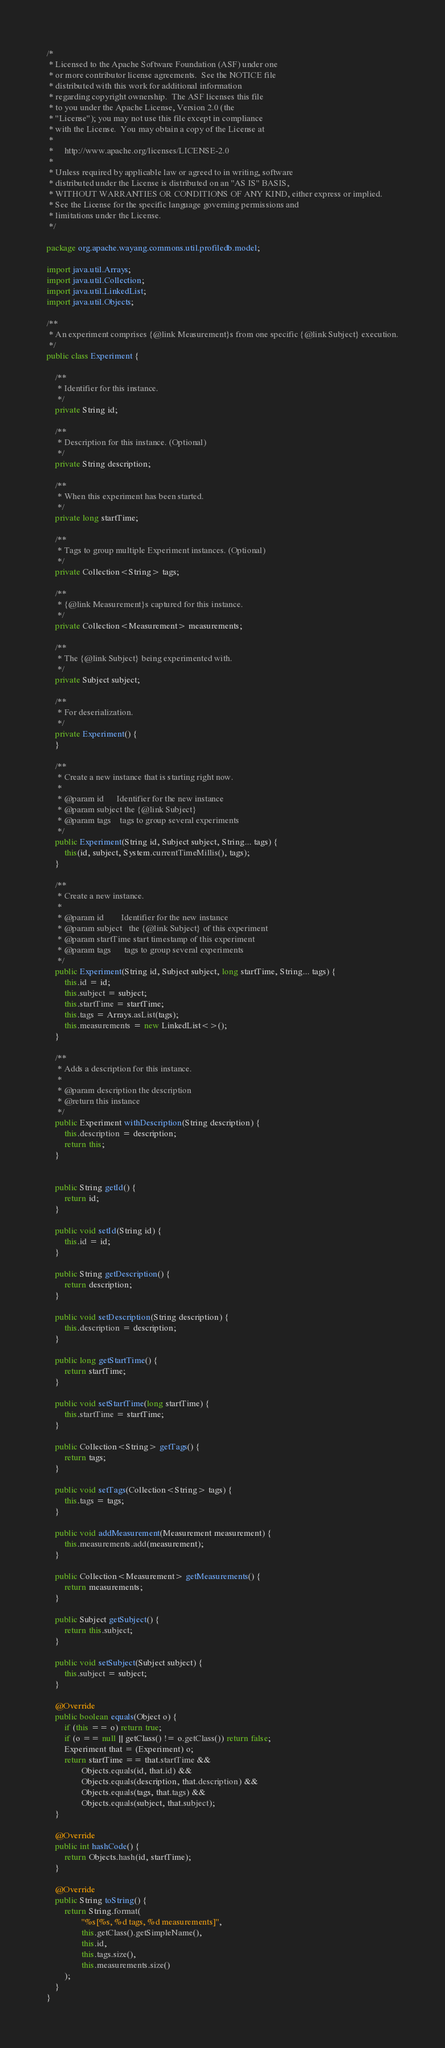<code> <loc_0><loc_0><loc_500><loc_500><_Java_>/*
 * Licensed to the Apache Software Foundation (ASF) under one
 * or more contributor license agreements.  See the NOTICE file
 * distributed with this work for additional information
 * regarding copyright ownership.  The ASF licenses this file
 * to you under the Apache License, Version 2.0 (the
 * "License"); you may not use this file except in compliance
 * with the License.  You may obtain a copy of the License at
 *
 *     http://www.apache.org/licenses/LICENSE-2.0
 *
 * Unless required by applicable law or agreed to in writing, software
 * distributed under the License is distributed on an "AS IS" BASIS,
 * WITHOUT WARRANTIES OR CONDITIONS OF ANY KIND, either express or implied.
 * See the License for the specific language governing permissions and
 * limitations under the License.
 */

package org.apache.wayang.commons.util.profiledb.model;

import java.util.Arrays;
import java.util.Collection;
import java.util.LinkedList;
import java.util.Objects;

/**
 * An experiment comprises {@link Measurement}s from one specific {@link Subject} execution.
 */
public class Experiment {

    /**
     * Identifier for this instance.
     */
    private String id;

    /**
     * Description for this instance. (Optional)
     */
    private String description;

    /**
     * When this experiment has been started.
     */
    private long startTime;

    /**
     * Tags to group multiple Experiment instances. (Optional)
     */
    private Collection<String> tags;

    /**
     * {@link Measurement}s captured for this instance.
     */
    private Collection<Measurement> measurements;

    /**
     * The {@link Subject} being experimented with.
     */
    private Subject subject;

    /**
     * For deserialization.
     */
    private Experiment() {
    }

    /**
     * Create a new instance that is starting right now.
     *
     * @param id      Identifier for the new instance
     * @param subject the {@link Subject}
     * @param tags    tags to group several experiments
     */
    public Experiment(String id, Subject subject, String... tags) {
        this(id, subject, System.currentTimeMillis(), tags);
    }

    /**
     * Create a new instance.
     *
     * @param id        Identifier for the new instance
     * @param subject   the {@link Subject} of this experiment
     * @param startTime start timestamp of this experiment
     * @param tags      tags to group several experiments
     */
    public Experiment(String id, Subject subject, long startTime, String... tags) {
        this.id = id;
        this.subject = subject;
        this.startTime = startTime;
        this.tags = Arrays.asList(tags);
        this.measurements = new LinkedList<>();
    }

    /**
     * Adds a description for this instance.
     *
     * @param description the description
     * @return this instance
     */
    public Experiment withDescription(String description) {
        this.description = description;
        return this;
    }


    public String getId() {
        return id;
    }

    public void setId(String id) {
        this.id = id;
    }

    public String getDescription() {
        return description;
    }

    public void setDescription(String description) {
        this.description = description;
    }

    public long getStartTime() {
        return startTime;
    }

    public void setStartTime(long startTime) {
        this.startTime = startTime;
    }

    public Collection<String> getTags() {
        return tags;
    }

    public void setTags(Collection<String> tags) {
        this.tags = tags;
    }

    public void addMeasurement(Measurement measurement) {
        this.measurements.add(measurement);
    }

    public Collection<Measurement> getMeasurements() {
        return measurements;
    }

    public Subject getSubject() {
        return this.subject;
    }

    public void setSubject(Subject subject) {
        this.subject = subject;
    }

    @Override
    public boolean equals(Object o) {
        if (this == o) return true;
        if (o == null || getClass() != o.getClass()) return false;
        Experiment that = (Experiment) o;
        return startTime == that.startTime &&
                Objects.equals(id, that.id) &&
                Objects.equals(description, that.description) &&
                Objects.equals(tags, that.tags) &&
                Objects.equals(subject, that.subject);
    }

    @Override
    public int hashCode() {
        return Objects.hash(id, startTime);
    }

    @Override
    public String toString() {
        return String.format(
                "%s[%s, %d tags, %d measurements]",
                this.getClass().getSimpleName(),
                this.id,
                this.tags.size(),
                this.measurements.size()
        );
    }
}
</code> 